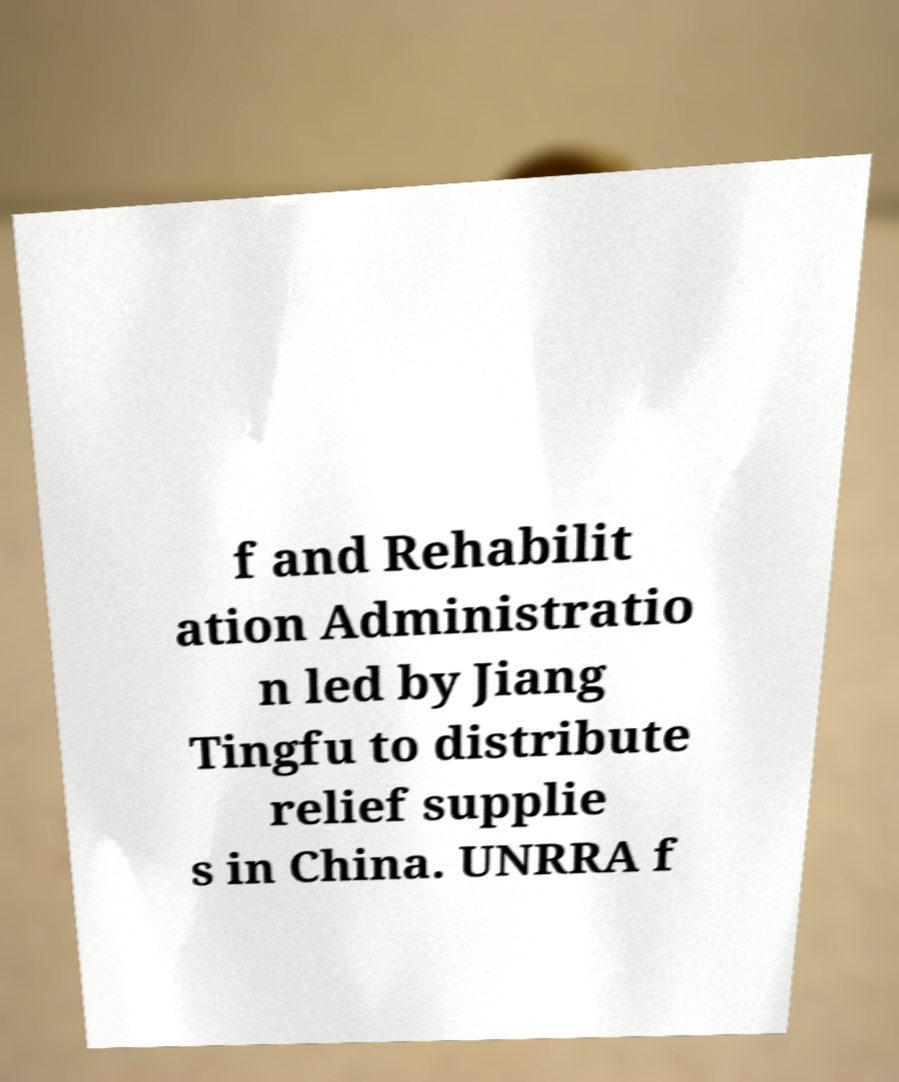For documentation purposes, I need the text within this image transcribed. Could you provide that? f and Rehabilit ation Administratio n led by Jiang Tingfu to distribute relief supplie s in China. UNRRA f 